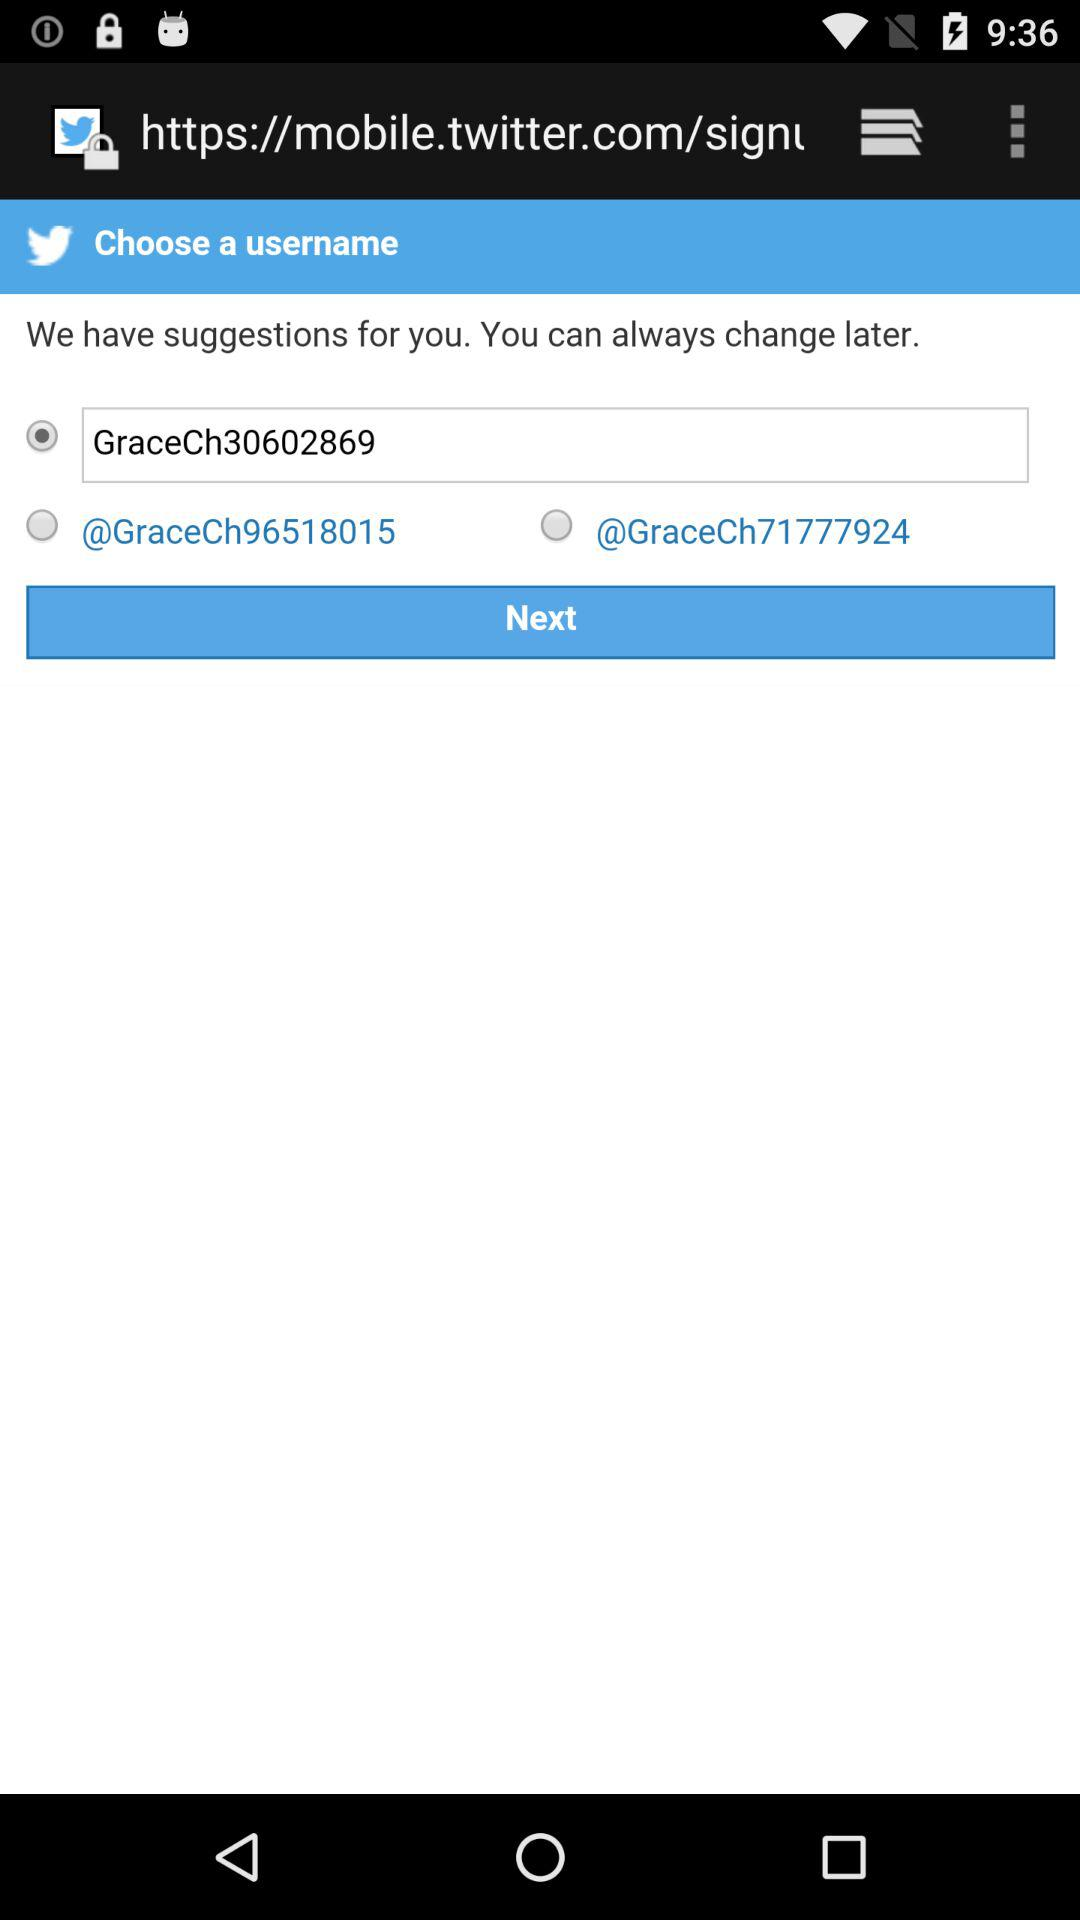Which option is selected? The selected option is "GraceCh30602869". 